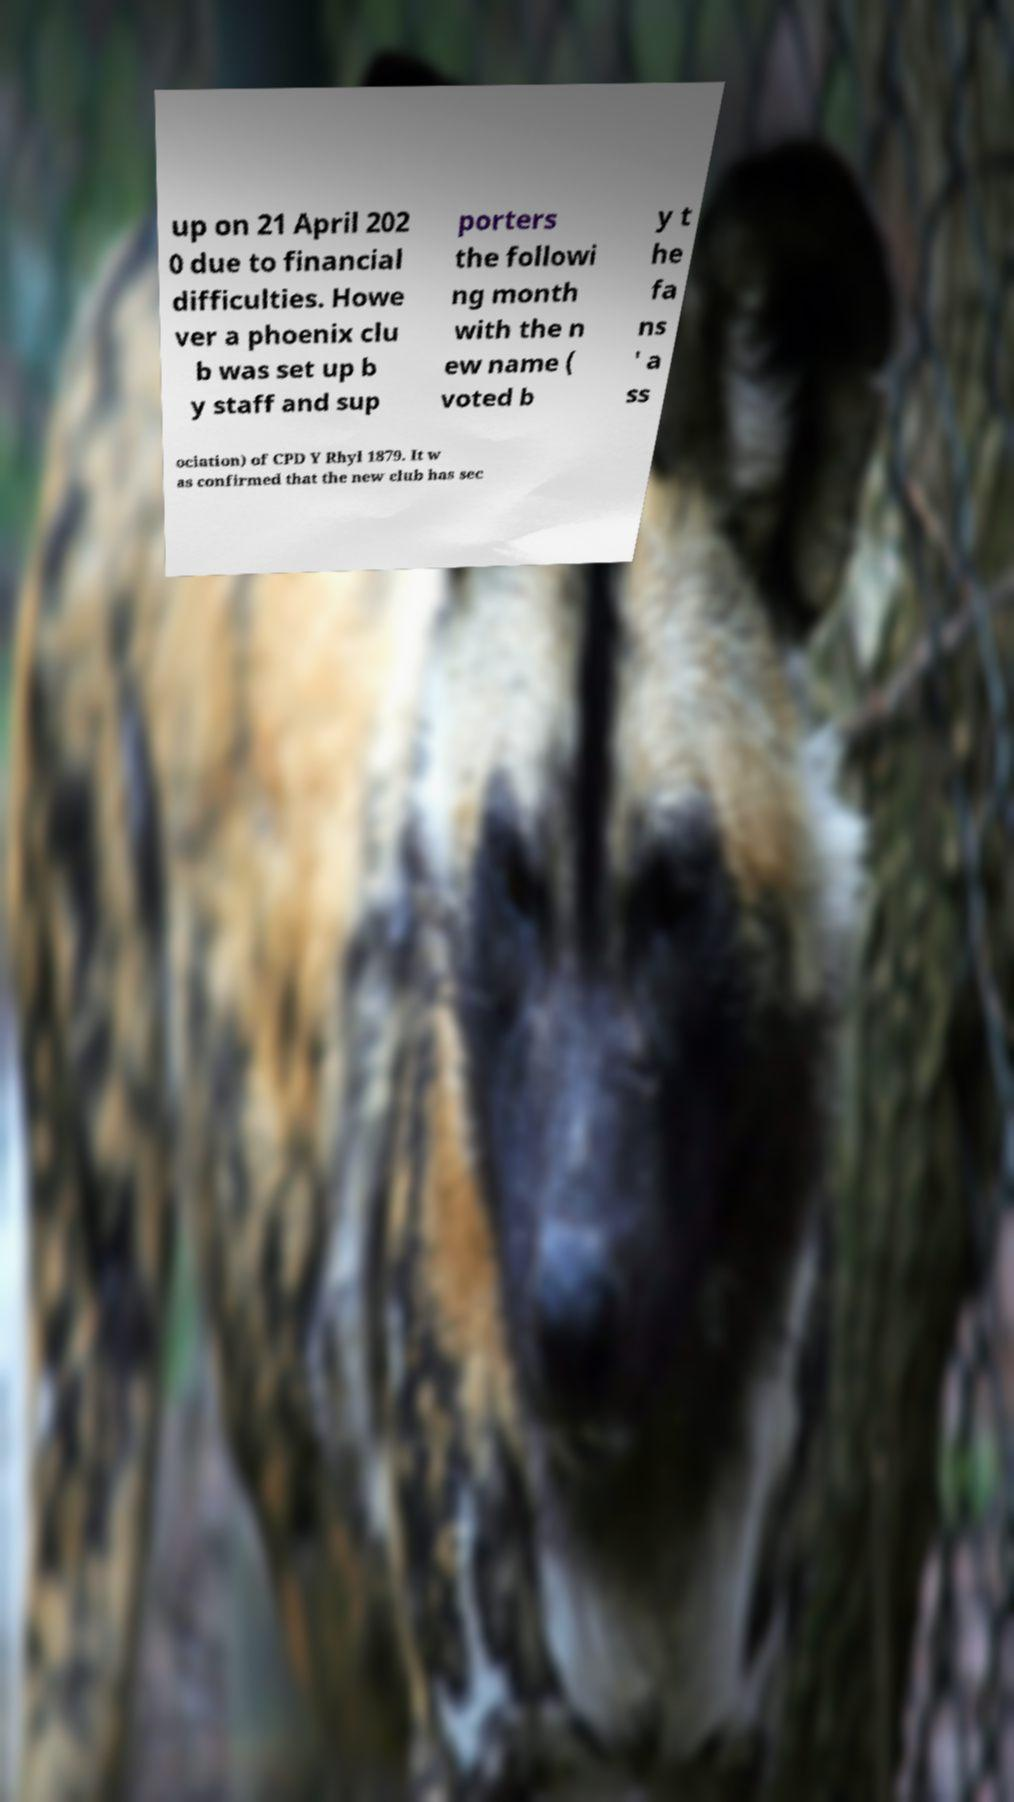There's text embedded in this image that I need extracted. Can you transcribe it verbatim? up on 21 April 202 0 due to financial difficulties. Howe ver a phoenix clu b was set up b y staff and sup porters the followi ng month with the n ew name ( voted b y t he fa ns ' a ss ociation) of CPD Y Rhyl 1879. It w as confirmed that the new club has sec 